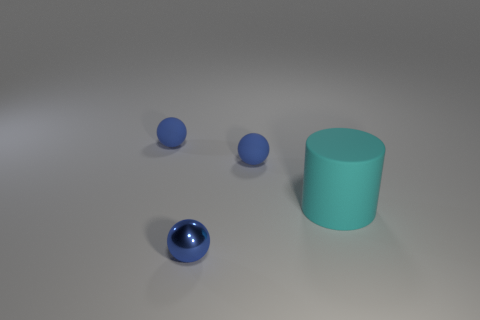If I wanted to create a physical arrangement mirroring this image, what considerations should I keep in mind regarding material and position? To recreate this arrangement, you'll need three spheres and one cylinder, each with distinct finishes: one sphere should have a reflective metallic texture, another a matte finish, and the third also matte but possibly rubber. Position the metallic sphere in front, with the matte ball to its left and slightly behind, then the cylinder to the right. The final sphere should lie further back to the left. Ensure the lighting is soft and from above to mimic the shadows cast in the image. 